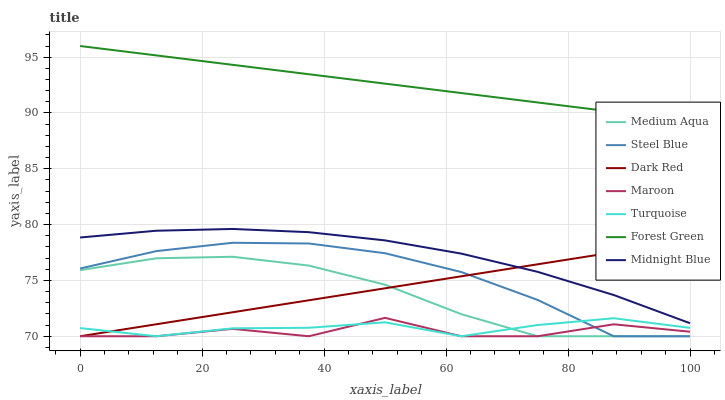Does Maroon have the minimum area under the curve?
Answer yes or no. Yes. Does Forest Green have the maximum area under the curve?
Answer yes or no. Yes. Does Midnight Blue have the minimum area under the curve?
Answer yes or no. No. Does Midnight Blue have the maximum area under the curve?
Answer yes or no. No. Is Dark Red the smoothest?
Answer yes or no. Yes. Is Maroon the roughest?
Answer yes or no. Yes. Is Midnight Blue the smoothest?
Answer yes or no. No. Is Midnight Blue the roughest?
Answer yes or no. No. Does Turquoise have the lowest value?
Answer yes or no. Yes. Does Midnight Blue have the lowest value?
Answer yes or no. No. Does Forest Green have the highest value?
Answer yes or no. Yes. Does Midnight Blue have the highest value?
Answer yes or no. No. Is Turquoise less than Midnight Blue?
Answer yes or no. Yes. Is Forest Green greater than Turquoise?
Answer yes or no. Yes. Does Maroon intersect Dark Red?
Answer yes or no. Yes. Is Maroon less than Dark Red?
Answer yes or no. No. Is Maroon greater than Dark Red?
Answer yes or no. No. Does Turquoise intersect Midnight Blue?
Answer yes or no. No. 